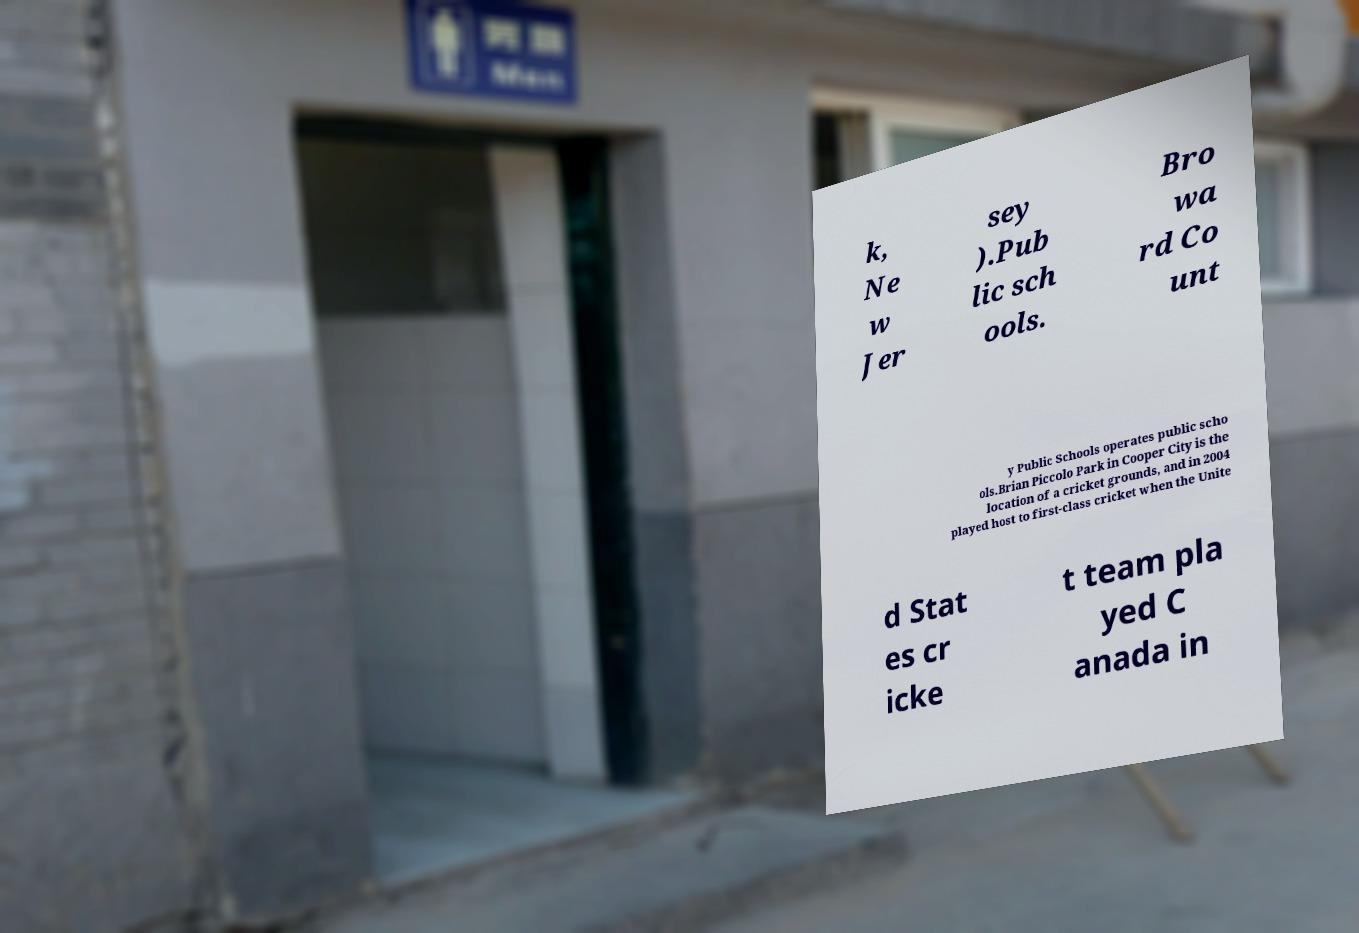Can you read and provide the text displayed in the image?This photo seems to have some interesting text. Can you extract and type it out for me? k, Ne w Jer sey ).Pub lic sch ools. Bro wa rd Co unt y Public Schools operates public scho ols.Brian Piccolo Park in Cooper City is the location of a cricket grounds, and in 2004 played host to first-class cricket when the Unite d Stat es cr icke t team pla yed C anada in 